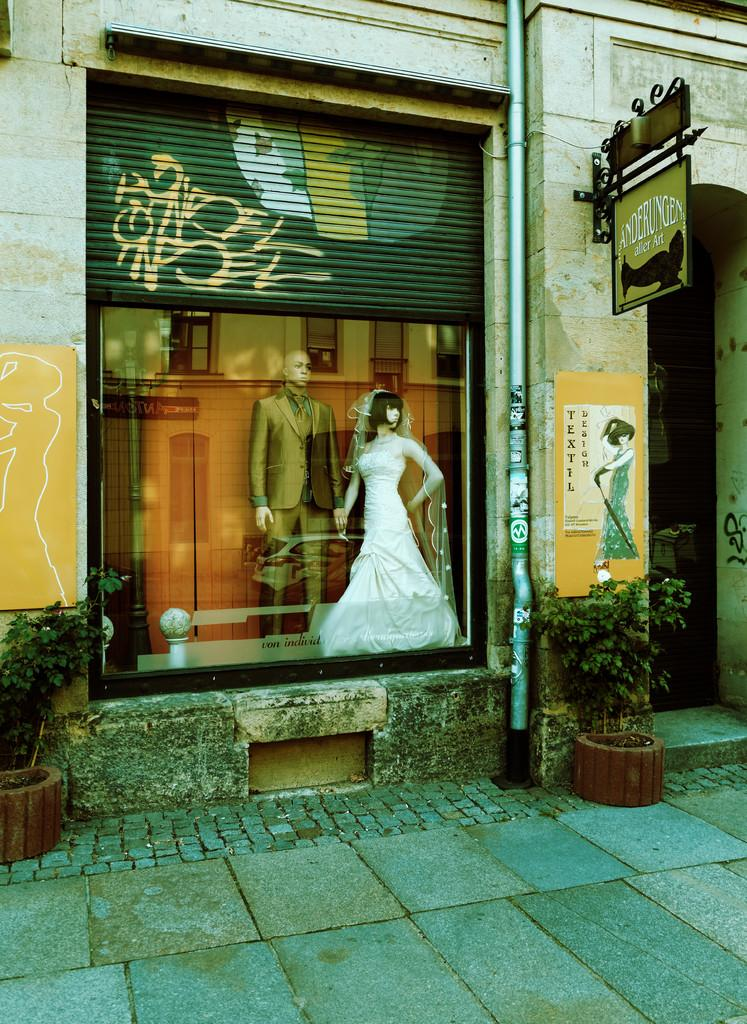What is in the foreground of the image? There is a pavement and two potted plants in the foreground of the image. What structures can be seen in the image? There is a wall, a pipe, a board, a shutter, and a poster in the image. What objects are present in the image? There are two mannequins and a glass in the image. What type of fruit is hanging from the boundary in the image? There is no boundary or fruit present in the image. What surprise can be seen in the image? There is no surprise visible in the image; it features a pavement, potted plants, a wall, a pipe, a board, a shutter, a poster, and two mannequins beside a glass. 